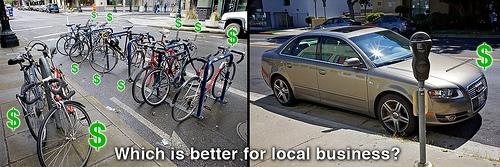Question: where was this photo taken?
Choices:
A. On the side of a road.
B. Pizza parlor.
C. Barber shop.
D. Hospital.
Answer with the letter. Answer: A Question: what is the photo?
Choices:
A. Truck.
B. Van.
C. Bus.
D. Car.
Answer with the letter. Answer: D Question: what else is in the photo?
Choices:
A. Bench.
B. Trash cans.
C. Bicycles.
D. Mail box.
Answer with the letter. Answer: C Question: who is in the photo?
Choices:
A. Hikers.
B. Swimmers.
C. Noone.
D. A bride and groom.
Answer with the letter. Answer: C 